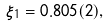<formula> <loc_0><loc_0><loc_500><loc_500>\xi _ { 1 } = 0 . 8 0 5 ( 2 ) ,</formula> 